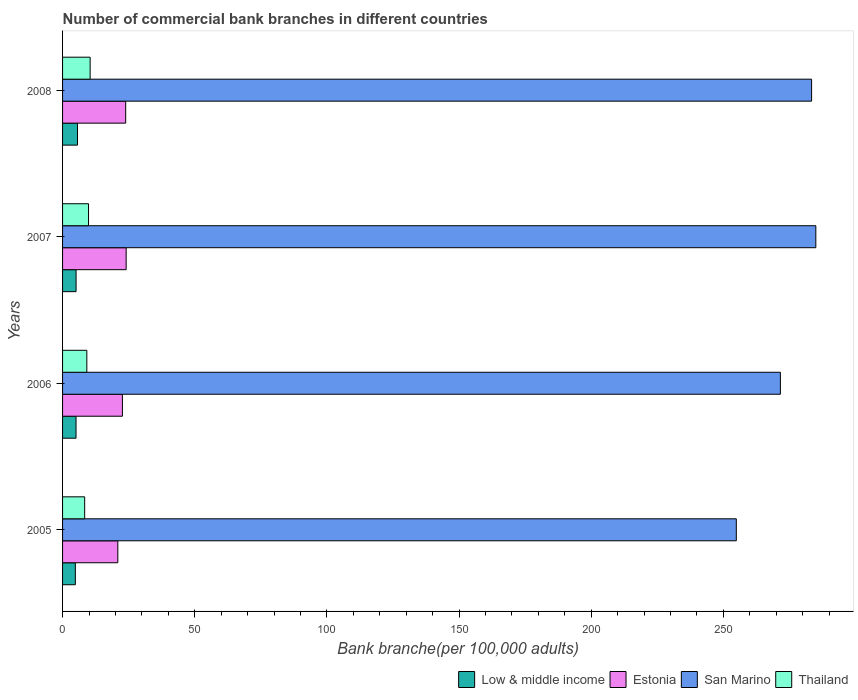How many groups of bars are there?
Offer a very short reply. 4. Are the number of bars per tick equal to the number of legend labels?
Offer a very short reply. Yes. Are the number of bars on each tick of the Y-axis equal?
Offer a very short reply. Yes. How many bars are there on the 3rd tick from the bottom?
Ensure brevity in your answer.  4. What is the label of the 2nd group of bars from the top?
Give a very brief answer. 2007. What is the number of commercial bank branches in Estonia in 2005?
Offer a terse response. 20.91. Across all years, what is the maximum number of commercial bank branches in Estonia?
Make the answer very short. 24.06. Across all years, what is the minimum number of commercial bank branches in Estonia?
Keep it short and to the point. 20.91. In which year was the number of commercial bank branches in Estonia minimum?
Your answer should be very brief. 2005. What is the total number of commercial bank branches in San Marino in the graph?
Your answer should be very brief. 1094.91. What is the difference between the number of commercial bank branches in Thailand in 2007 and that in 2008?
Make the answer very short. -0.61. What is the difference between the number of commercial bank branches in San Marino in 2006 and the number of commercial bank branches in Estonia in 2007?
Make the answer very short. 247.53. What is the average number of commercial bank branches in Low & middle income per year?
Your response must be concise. 5.17. In the year 2008, what is the difference between the number of commercial bank branches in San Marino and number of commercial bank branches in Estonia?
Ensure brevity in your answer.  259.52. In how many years, is the number of commercial bank branches in Estonia greater than 220 ?
Offer a very short reply. 0. What is the ratio of the number of commercial bank branches in Estonia in 2007 to that in 2008?
Ensure brevity in your answer.  1.01. What is the difference between the highest and the second highest number of commercial bank branches in Estonia?
Offer a terse response. 0.18. What is the difference between the highest and the lowest number of commercial bank branches in San Marino?
Give a very brief answer. 30.09. What does the 1st bar from the top in 2005 represents?
Provide a short and direct response. Thailand. What does the 2nd bar from the bottom in 2005 represents?
Provide a short and direct response. Estonia. How many bars are there?
Offer a terse response. 16. Are all the bars in the graph horizontal?
Provide a short and direct response. Yes. How many years are there in the graph?
Offer a terse response. 4. What is the difference between two consecutive major ticks on the X-axis?
Your response must be concise. 50. Are the values on the major ticks of X-axis written in scientific E-notation?
Keep it short and to the point. No. Does the graph contain any zero values?
Make the answer very short. No. How are the legend labels stacked?
Offer a terse response. Horizontal. What is the title of the graph?
Give a very brief answer. Number of commercial bank branches in different countries. Does "Least developed countries" appear as one of the legend labels in the graph?
Provide a succinct answer. No. What is the label or title of the X-axis?
Make the answer very short. Bank branche(per 100,0 adults). What is the label or title of the Y-axis?
Your response must be concise. Years. What is the Bank branche(per 100,000 adults) of Low & middle income in 2005?
Your response must be concise. 4.83. What is the Bank branche(per 100,000 adults) in Estonia in 2005?
Keep it short and to the point. 20.91. What is the Bank branche(per 100,000 adults) of San Marino in 2005?
Keep it short and to the point. 254.92. What is the Bank branche(per 100,000 adults) in Thailand in 2005?
Keep it short and to the point. 8.36. What is the Bank branche(per 100,000 adults) in Low & middle income in 2006?
Offer a terse response. 5.09. What is the Bank branche(per 100,000 adults) in Estonia in 2006?
Make the answer very short. 22.65. What is the Bank branche(per 100,000 adults) of San Marino in 2006?
Keep it short and to the point. 271.59. What is the Bank branche(per 100,000 adults) of Thailand in 2006?
Offer a very short reply. 9.18. What is the Bank branche(per 100,000 adults) of Low & middle income in 2007?
Your response must be concise. 5.11. What is the Bank branche(per 100,000 adults) of Estonia in 2007?
Provide a succinct answer. 24.06. What is the Bank branche(per 100,000 adults) of San Marino in 2007?
Make the answer very short. 285. What is the Bank branche(per 100,000 adults) of Thailand in 2007?
Give a very brief answer. 9.82. What is the Bank branche(per 100,000 adults) in Low & middle income in 2008?
Keep it short and to the point. 5.65. What is the Bank branche(per 100,000 adults) of Estonia in 2008?
Your answer should be very brief. 23.88. What is the Bank branche(per 100,000 adults) in San Marino in 2008?
Your response must be concise. 283.4. What is the Bank branche(per 100,000 adults) of Thailand in 2008?
Your answer should be very brief. 10.44. Across all years, what is the maximum Bank branche(per 100,000 adults) in Low & middle income?
Your answer should be very brief. 5.65. Across all years, what is the maximum Bank branche(per 100,000 adults) of Estonia?
Give a very brief answer. 24.06. Across all years, what is the maximum Bank branche(per 100,000 adults) in San Marino?
Offer a very short reply. 285. Across all years, what is the maximum Bank branche(per 100,000 adults) in Thailand?
Offer a terse response. 10.44. Across all years, what is the minimum Bank branche(per 100,000 adults) of Low & middle income?
Provide a short and direct response. 4.83. Across all years, what is the minimum Bank branche(per 100,000 adults) of Estonia?
Keep it short and to the point. 20.91. Across all years, what is the minimum Bank branche(per 100,000 adults) of San Marino?
Provide a succinct answer. 254.92. Across all years, what is the minimum Bank branche(per 100,000 adults) in Thailand?
Provide a succinct answer. 8.36. What is the total Bank branche(per 100,000 adults) of Low & middle income in the graph?
Offer a very short reply. 20.69. What is the total Bank branche(per 100,000 adults) of Estonia in the graph?
Give a very brief answer. 91.5. What is the total Bank branche(per 100,000 adults) in San Marino in the graph?
Make the answer very short. 1094.91. What is the total Bank branche(per 100,000 adults) of Thailand in the graph?
Make the answer very short. 37.8. What is the difference between the Bank branche(per 100,000 adults) in Low & middle income in 2005 and that in 2006?
Offer a terse response. -0.26. What is the difference between the Bank branche(per 100,000 adults) in Estonia in 2005 and that in 2006?
Ensure brevity in your answer.  -1.74. What is the difference between the Bank branche(per 100,000 adults) in San Marino in 2005 and that in 2006?
Your response must be concise. -16.68. What is the difference between the Bank branche(per 100,000 adults) in Thailand in 2005 and that in 2006?
Keep it short and to the point. -0.82. What is the difference between the Bank branche(per 100,000 adults) in Low & middle income in 2005 and that in 2007?
Offer a terse response. -0.28. What is the difference between the Bank branche(per 100,000 adults) of Estonia in 2005 and that in 2007?
Provide a short and direct response. -3.15. What is the difference between the Bank branche(per 100,000 adults) of San Marino in 2005 and that in 2007?
Offer a very short reply. -30.09. What is the difference between the Bank branche(per 100,000 adults) of Thailand in 2005 and that in 2007?
Give a very brief answer. -1.46. What is the difference between the Bank branche(per 100,000 adults) in Low & middle income in 2005 and that in 2008?
Your response must be concise. -0.81. What is the difference between the Bank branche(per 100,000 adults) of Estonia in 2005 and that in 2008?
Your answer should be compact. -2.97. What is the difference between the Bank branche(per 100,000 adults) of San Marino in 2005 and that in 2008?
Give a very brief answer. -28.48. What is the difference between the Bank branche(per 100,000 adults) of Thailand in 2005 and that in 2008?
Your answer should be very brief. -2.07. What is the difference between the Bank branche(per 100,000 adults) of Low & middle income in 2006 and that in 2007?
Give a very brief answer. -0.02. What is the difference between the Bank branche(per 100,000 adults) in Estonia in 2006 and that in 2007?
Provide a short and direct response. -1.41. What is the difference between the Bank branche(per 100,000 adults) in San Marino in 2006 and that in 2007?
Provide a succinct answer. -13.41. What is the difference between the Bank branche(per 100,000 adults) in Thailand in 2006 and that in 2007?
Provide a short and direct response. -0.64. What is the difference between the Bank branche(per 100,000 adults) of Low & middle income in 2006 and that in 2008?
Your answer should be very brief. -0.55. What is the difference between the Bank branche(per 100,000 adults) of Estonia in 2006 and that in 2008?
Offer a terse response. -1.23. What is the difference between the Bank branche(per 100,000 adults) in San Marino in 2006 and that in 2008?
Your answer should be very brief. -11.8. What is the difference between the Bank branche(per 100,000 adults) in Thailand in 2006 and that in 2008?
Your answer should be very brief. -1.26. What is the difference between the Bank branche(per 100,000 adults) in Low & middle income in 2007 and that in 2008?
Your answer should be very brief. -0.53. What is the difference between the Bank branche(per 100,000 adults) in Estonia in 2007 and that in 2008?
Offer a terse response. 0.18. What is the difference between the Bank branche(per 100,000 adults) of San Marino in 2007 and that in 2008?
Provide a succinct answer. 1.6. What is the difference between the Bank branche(per 100,000 adults) in Thailand in 2007 and that in 2008?
Your answer should be very brief. -0.61. What is the difference between the Bank branche(per 100,000 adults) in Low & middle income in 2005 and the Bank branche(per 100,000 adults) in Estonia in 2006?
Offer a terse response. -17.82. What is the difference between the Bank branche(per 100,000 adults) in Low & middle income in 2005 and the Bank branche(per 100,000 adults) in San Marino in 2006?
Provide a short and direct response. -266.76. What is the difference between the Bank branche(per 100,000 adults) in Low & middle income in 2005 and the Bank branche(per 100,000 adults) in Thailand in 2006?
Offer a very short reply. -4.35. What is the difference between the Bank branche(per 100,000 adults) of Estonia in 2005 and the Bank branche(per 100,000 adults) of San Marino in 2006?
Provide a succinct answer. -250.68. What is the difference between the Bank branche(per 100,000 adults) in Estonia in 2005 and the Bank branche(per 100,000 adults) in Thailand in 2006?
Give a very brief answer. 11.73. What is the difference between the Bank branche(per 100,000 adults) of San Marino in 2005 and the Bank branche(per 100,000 adults) of Thailand in 2006?
Keep it short and to the point. 245.74. What is the difference between the Bank branche(per 100,000 adults) of Low & middle income in 2005 and the Bank branche(per 100,000 adults) of Estonia in 2007?
Give a very brief answer. -19.23. What is the difference between the Bank branche(per 100,000 adults) in Low & middle income in 2005 and the Bank branche(per 100,000 adults) in San Marino in 2007?
Ensure brevity in your answer.  -280.17. What is the difference between the Bank branche(per 100,000 adults) of Low & middle income in 2005 and the Bank branche(per 100,000 adults) of Thailand in 2007?
Offer a terse response. -4.99. What is the difference between the Bank branche(per 100,000 adults) in Estonia in 2005 and the Bank branche(per 100,000 adults) in San Marino in 2007?
Ensure brevity in your answer.  -264.09. What is the difference between the Bank branche(per 100,000 adults) of Estonia in 2005 and the Bank branche(per 100,000 adults) of Thailand in 2007?
Give a very brief answer. 11.09. What is the difference between the Bank branche(per 100,000 adults) in San Marino in 2005 and the Bank branche(per 100,000 adults) in Thailand in 2007?
Your response must be concise. 245.09. What is the difference between the Bank branche(per 100,000 adults) of Low & middle income in 2005 and the Bank branche(per 100,000 adults) of Estonia in 2008?
Ensure brevity in your answer.  -19.05. What is the difference between the Bank branche(per 100,000 adults) of Low & middle income in 2005 and the Bank branche(per 100,000 adults) of San Marino in 2008?
Ensure brevity in your answer.  -278.56. What is the difference between the Bank branche(per 100,000 adults) in Low & middle income in 2005 and the Bank branche(per 100,000 adults) in Thailand in 2008?
Keep it short and to the point. -5.6. What is the difference between the Bank branche(per 100,000 adults) in Estonia in 2005 and the Bank branche(per 100,000 adults) in San Marino in 2008?
Provide a short and direct response. -262.49. What is the difference between the Bank branche(per 100,000 adults) of Estonia in 2005 and the Bank branche(per 100,000 adults) of Thailand in 2008?
Offer a very short reply. 10.48. What is the difference between the Bank branche(per 100,000 adults) of San Marino in 2005 and the Bank branche(per 100,000 adults) of Thailand in 2008?
Make the answer very short. 244.48. What is the difference between the Bank branche(per 100,000 adults) in Low & middle income in 2006 and the Bank branche(per 100,000 adults) in Estonia in 2007?
Your response must be concise. -18.96. What is the difference between the Bank branche(per 100,000 adults) of Low & middle income in 2006 and the Bank branche(per 100,000 adults) of San Marino in 2007?
Provide a succinct answer. -279.91. What is the difference between the Bank branche(per 100,000 adults) of Low & middle income in 2006 and the Bank branche(per 100,000 adults) of Thailand in 2007?
Your answer should be very brief. -4.73. What is the difference between the Bank branche(per 100,000 adults) of Estonia in 2006 and the Bank branche(per 100,000 adults) of San Marino in 2007?
Keep it short and to the point. -262.35. What is the difference between the Bank branche(per 100,000 adults) in Estonia in 2006 and the Bank branche(per 100,000 adults) in Thailand in 2007?
Provide a succinct answer. 12.83. What is the difference between the Bank branche(per 100,000 adults) of San Marino in 2006 and the Bank branche(per 100,000 adults) of Thailand in 2007?
Your answer should be very brief. 261.77. What is the difference between the Bank branche(per 100,000 adults) in Low & middle income in 2006 and the Bank branche(per 100,000 adults) in Estonia in 2008?
Provide a short and direct response. -18.79. What is the difference between the Bank branche(per 100,000 adults) in Low & middle income in 2006 and the Bank branche(per 100,000 adults) in San Marino in 2008?
Offer a terse response. -278.3. What is the difference between the Bank branche(per 100,000 adults) of Low & middle income in 2006 and the Bank branche(per 100,000 adults) of Thailand in 2008?
Provide a succinct answer. -5.34. What is the difference between the Bank branche(per 100,000 adults) in Estonia in 2006 and the Bank branche(per 100,000 adults) in San Marino in 2008?
Make the answer very short. -260.75. What is the difference between the Bank branche(per 100,000 adults) of Estonia in 2006 and the Bank branche(per 100,000 adults) of Thailand in 2008?
Offer a very short reply. 12.21. What is the difference between the Bank branche(per 100,000 adults) of San Marino in 2006 and the Bank branche(per 100,000 adults) of Thailand in 2008?
Offer a very short reply. 261.16. What is the difference between the Bank branche(per 100,000 adults) of Low & middle income in 2007 and the Bank branche(per 100,000 adults) of Estonia in 2008?
Make the answer very short. -18.77. What is the difference between the Bank branche(per 100,000 adults) of Low & middle income in 2007 and the Bank branche(per 100,000 adults) of San Marino in 2008?
Ensure brevity in your answer.  -278.28. What is the difference between the Bank branche(per 100,000 adults) of Low & middle income in 2007 and the Bank branche(per 100,000 adults) of Thailand in 2008?
Keep it short and to the point. -5.32. What is the difference between the Bank branche(per 100,000 adults) in Estonia in 2007 and the Bank branche(per 100,000 adults) in San Marino in 2008?
Your response must be concise. -259.34. What is the difference between the Bank branche(per 100,000 adults) in Estonia in 2007 and the Bank branche(per 100,000 adults) in Thailand in 2008?
Ensure brevity in your answer.  13.62. What is the difference between the Bank branche(per 100,000 adults) in San Marino in 2007 and the Bank branche(per 100,000 adults) in Thailand in 2008?
Your answer should be very brief. 274.57. What is the average Bank branche(per 100,000 adults) in Low & middle income per year?
Offer a terse response. 5.17. What is the average Bank branche(per 100,000 adults) of Estonia per year?
Offer a terse response. 22.87. What is the average Bank branche(per 100,000 adults) in San Marino per year?
Your response must be concise. 273.73. What is the average Bank branche(per 100,000 adults) in Thailand per year?
Make the answer very short. 9.45. In the year 2005, what is the difference between the Bank branche(per 100,000 adults) in Low & middle income and Bank branche(per 100,000 adults) in Estonia?
Keep it short and to the point. -16.08. In the year 2005, what is the difference between the Bank branche(per 100,000 adults) in Low & middle income and Bank branche(per 100,000 adults) in San Marino?
Your answer should be compact. -250.08. In the year 2005, what is the difference between the Bank branche(per 100,000 adults) of Low & middle income and Bank branche(per 100,000 adults) of Thailand?
Ensure brevity in your answer.  -3.53. In the year 2005, what is the difference between the Bank branche(per 100,000 adults) of Estonia and Bank branche(per 100,000 adults) of San Marino?
Provide a short and direct response. -234.01. In the year 2005, what is the difference between the Bank branche(per 100,000 adults) in Estonia and Bank branche(per 100,000 adults) in Thailand?
Offer a terse response. 12.55. In the year 2005, what is the difference between the Bank branche(per 100,000 adults) in San Marino and Bank branche(per 100,000 adults) in Thailand?
Your answer should be very brief. 246.55. In the year 2006, what is the difference between the Bank branche(per 100,000 adults) of Low & middle income and Bank branche(per 100,000 adults) of Estonia?
Offer a terse response. -17.55. In the year 2006, what is the difference between the Bank branche(per 100,000 adults) of Low & middle income and Bank branche(per 100,000 adults) of San Marino?
Offer a terse response. -266.5. In the year 2006, what is the difference between the Bank branche(per 100,000 adults) in Low & middle income and Bank branche(per 100,000 adults) in Thailand?
Keep it short and to the point. -4.08. In the year 2006, what is the difference between the Bank branche(per 100,000 adults) of Estonia and Bank branche(per 100,000 adults) of San Marino?
Your response must be concise. -248.94. In the year 2006, what is the difference between the Bank branche(per 100,000 adults) of Estonia and Bank branche(per 100,000 adults) of Thailand?
Provide a short and direct response. 13.47. In the year 2006, what is the difference between the Bank branche(per 100,000 adults) of San Marino and Bank branche(per 100,000 adults) of Thailand?
Offer a very short reply. 262.41. In the year 2007, what is the difference between the Bank branche(per 100,000 adults) of Low & middle income and Bank branche(per 100,000 adults) of Estonia?
Offer a very short reply. -18.95. In the year 2007, what is the difference between the Bank branche(per 100,000 adults) in Low & middle income and Bank branche(per 100,000 adults) in San Marino?
Provide a succinct answer. -279.89. In the year 2007, what is the difference between the Bank branche(per 100,000 adults) in Low & middle income and Bank branche(per 100,000 adults) in Thailand?
Provide a short and direct response. -4.71. In the year 2007, what is the difference between the Bank branche(per 100,000 adults) of Estonia and Bank branche(per 100,000 adults) of San Marino?
Ensure brevity in your answer.  -260.94. In the year 2007, what is the difference between the Bank branche(per 100,000 adults) of Estonia and Bank branche(per 100,000 adults) of Thailand?
Your answer should be compact. 14.24. In the year 2007, what is the difference between the Bank branche(per 100,000 adults) in San Marino and Bank branche(per 100,000 adults) in Thailand?
Ensure brevity in your answer.  275.18. In the year 2008, what is the difference between the Bank branche(per 100,000 adults) of Low & middle income and Bank branche(per 100,000 adults) of Estonia?
Give a very brief answer. -18.23. In the year 2008, what is the difference between the Bank branche(per 100,000 adults) of Low & middle income and Bank branche(per 100,000 adults) of San Marino?
Your response must be concise. -277.75. In the year 2008, what is the difference between the Bank branche(per 100,000 adults) in Low & middle income and Bank branche(per 100,000 adults) in Thailand?
Offer a very short reply. -4.79. In the year 2008, what is the difference between the Bank branche(per 100,000 adults) of Estonia and Bank branche(per 100,000 adults) of San Marino?
Your answer should be very brief. -259.52. In the year 2008, what is the difference between the Bank branche(per 100,000 adults) of Estonia and Bank branche(per 100,000 adults) of Thailand?
Make the answer very short. 13.44. In the year 2008, what is the difference between the Bank branche(per 100,000 adults) of San Marino and Bank branche(per 100,000 adults) of Thailand?
Offer a very short reply. 272.96. What is the ratio of the Bank branche(per 100,000 adults) of Low & middle income in 2005 to that in 2006?
Keep it short and to the point. 0.95. What is the ratio of the Bank branche(per 100,000 adults) of Estonia in 2005 to that in 2006?
Provide a short and direct response. 0.92. What is the ratio of the Bank branche(per 100,000 adults) of San Marino in 2005 to that in 2006?
Keep it short and to the point. 0.94. What is the ratio of the Bank branche(per 100,000 adults) in Thailand in 2005 to that in 2006?
Make the answer very short. 0.91. What is the ratio of the Bank branche(per 100,000 adults) in Low & middle income in 2005 to that in 2007?
Ensure brevity in your answer.  0.95. What is the ratio of the Bank branche(per 100,000 adults) in Estonia in 2005 to that in 2007?
Provide a short and direct response. 0.87. What is the ratio of the Bank branche(per 100,000 adults) in San Marino in 2005 to that in 2007?
Make the answer very short. 0.89. What is the ratio of the Bank branche(per 100,000 adults) in Thailand in 2005 to that in 2007?
Your answer should be very brief. 0.85. What is the ratio of the Bank branche(per 100,000 adults) in Low & middle income in 2005 to that in 2008?
Your response must be concise. 0.86. What is the ratio of the Bank branche(per 100,000 adults) in Estonia in 2005 to that in 2008?
Your response must be concise. 0.88. What is the ratio of the Bank branche(per 100,000 adults) of San Marino in 2005 to that in 2008?
Offer a very short reply. 0.9. What is the ratio of the Bank branche(per 100,000 adults) of Thailand in 2005 to that in 2008?
Keep it short and to the point. 0.8. What is the ratio of the Bank branche(per 100,000 adults) of Low & middle income in 2006 to that in 2007?
Keep it short and to the point. 1. What is the ratio of the Bank branche(per 100,000 adults) of Estonia in 2006 to that in 2007?
Offer a terse response. 0.94. What is the ratio of the Bank branche(per 100,000 adults) of San Marino in 2006 to that in 2007?
Your answer should be compact. 0.95. What is the ratio of the Bank branche(per 100,000 adults) of Thailand in 2006 to that in 2007?
Offer a terse response. 0.93. What is the ratio of the Bank branche(per 100,000 adults) in Low & middle income in 2006 to that in 2008?
Make the answer very short. 0.9. What is the ratio of the Bank branche(per 100,000 adults) of Estonia in 2006 to that in 2008?
Give a very brief answer. 0.95. What is the ratio of the Bank branche(per 100,000 adults) in Thailand in 2006 to that in 2008?
Ensure brevity in your answer.  0.88. What is the ratio of the Bank branche(per 100,000 adults) of Low & middle income in 2007 to that in 2008?
Make the answer very short. 0.91. What is the ratio of the Bank branche(per 100,000 adults) in Estonia in 2007 to that in 2008?
Make the answer very short. 1.01. What is the ratio of the Bank branche(per 100,000 adults) in Thailand in 2007 to that in 2008?
Offer a terse response. 0.94. What is the difference between the highest and the second highest Bank branche(per 100,000 adults) of Low & middle income?
Provide a succinct answer. 0.53. What is the difference between the highest and the second highest Bank branche(per 100,000 adults) of Estonia?
Your answer should be compact. 0.18. What is the difference between the highest and the second highest Bank branche(per 100,000 adults) in San Marino?
Offer a terse response. 1.6. What is the difference between the highest and the second highest Bank branche(per 100,000 adults) in Thailand?
Provide a succinct answer. 0.61. What is the difference between the highest and the lowest Bank branche(per 100,000 adults) in Low & middle income?
Provide a succinct answer. 0.81. What is the difference between the highest and the lowest Bank branche(per 100,000 adults) in Estonia?
Your answer should be compact. 3.15. What is the difference between the highest and the lowest Bank branche(per 100,000 adults) of San Marino?
Provide a short and direct response. 30.09. What is the difference between the highest and the lowest Bank branche(per 100,000 adults) of Thailand?
Provide a succinct answer. 2.07. 